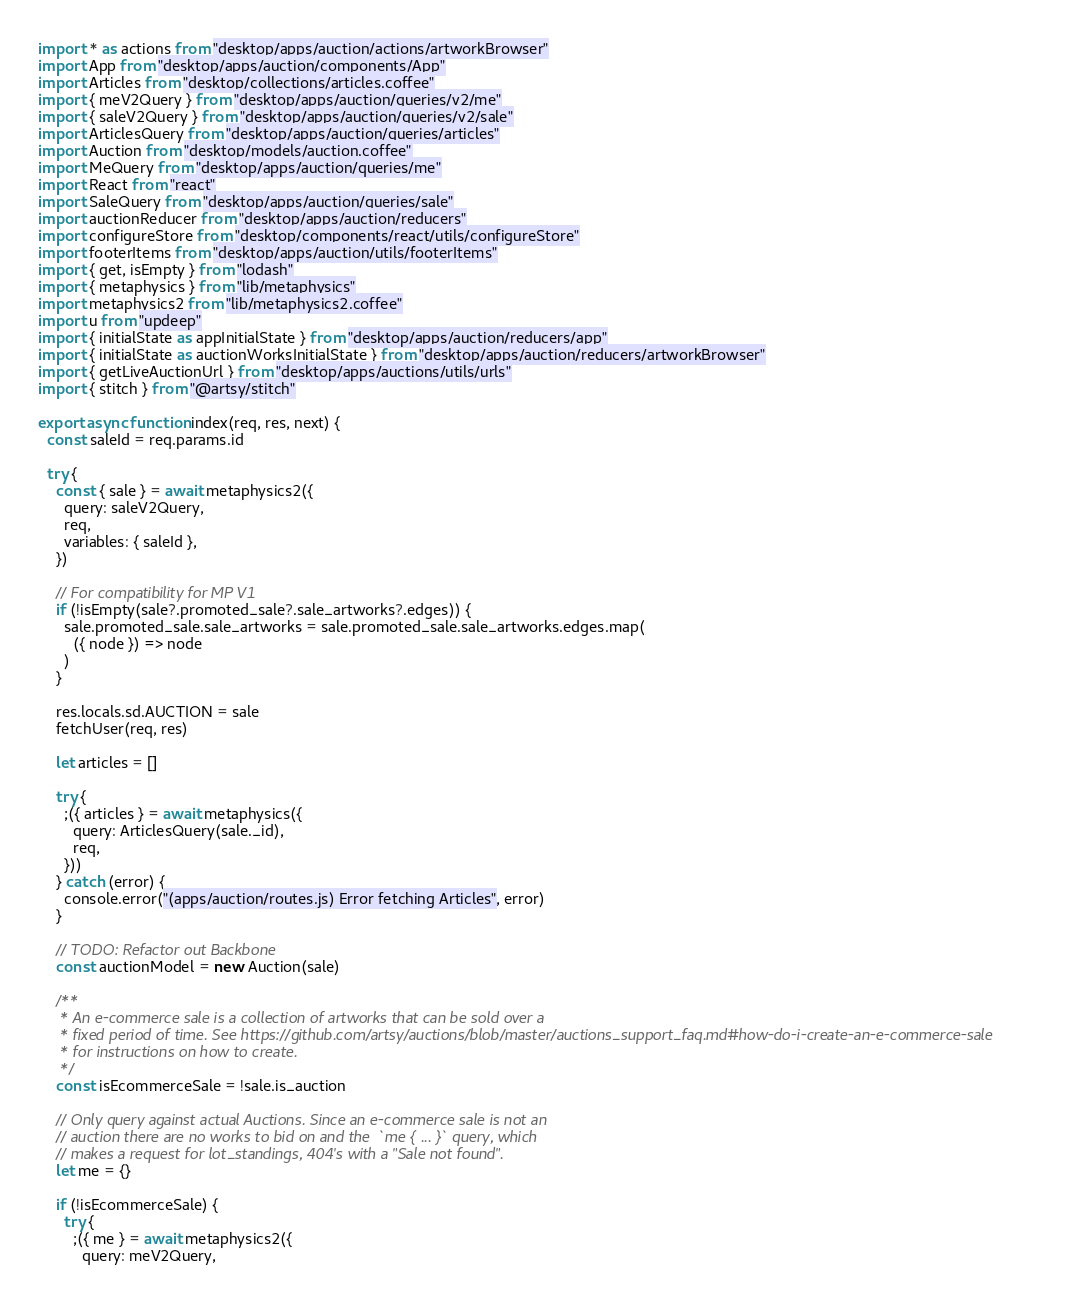<code> <loc_0><loc_0><loc_500><loc_500><_JavaScript_>import * as actions from "desktop/apps/auction/actions/artworkBrowser"
import App from "desktop/apps/auction/components/App"
import Articles from "desktop/collections/articles.coffee"
import { meV2Query } from "desktop/apps/auction/queries/v2/me"
import { saleV2Query } from "desktop/apps/auction/queries/v2/sale"
import ArticlesQuery from "desktop/apps/auction/queries/articles"
import Auction from "desktop/models/auction.coffee"
import MeQuery from "desktop/apps/auction/queries/me"
import React from "react"
import SaleQuery from "desktop/apps/auction/queries/sale"
import auctionReducer from "desktop/apps/auction/reducers"
import configureStore from "desktop/components/react/utils/configureStore"
import footerItems from "desktop/apps/auction/utils/footerItems"
import { get, isEmpty } from "lodash"
import { metaphysics } from "lib/metaphysics"
import metaphysics2 from "lib/metaphysics2.coffee"
import u from "updeep"
import { initialState as appInitialState } from "desktop/apps/auction/reducers/app"
import { initialState as auctionWorksInitialState } from "desktop/apps/auction/reducers/artworkBrowser"
import { getLiveAuctionUrl } from "desktop/apps/auctions/utils/urls"
import { stitch } from "@artsy/stitch"

export async function index(req, res, next) {
  const saleId = req.params.id

  try {
    const { sale } = await metaphysics2({
      query: saleV2Query,
      req,
      variables: { saleId },
    })

    // For compatibility for MP V1
    if (!isEmpty(sale?.promoted_sale?.sale_artworks?.edges)) {
      sale.promoted_sale.sale_artworks = sale.promoted_sale.sale_artworks.edges.map(
        ({ node }) => node
      )
    }

    res.locals.sd.AUCTION = sale
    fetchUser(req, res)

    let articles = []

    try {
      ;({ articles } = await metaphysics({
        query: ArticlesQuery(sale._id),
        req,
      }))
    } catch (error) {
      console.error("(apps/auction/routes.js) Error fetching Articles", error)
    }

    // TODO: Refactor out Backbone
    const auctionModel = new Auction(sale)

    /**
     * An e-commerce sale is a collection of artworks that can be sold over a
     * fixed period of time. See https://github.com/artsy/auctions/blob/master/auctions_support_faq.md#how-do-i-create-an-e-commerce-sale
     * for instructions on how to create.
     */
    const isEcommerceSale = !sale.is_auction

    // Only query against actual Auctions. Since an e-commerce sale is not an
    // auction there are no works to bid on and the  `me { ... }` query, which
    // makes a request for lot_standings, 404's with a "Sale not found".
    let me = {}

    if (!isEcommerceSale) {
      try {
        ;({ me } = await metaphysics2({
          query: meV2Query,</code> 